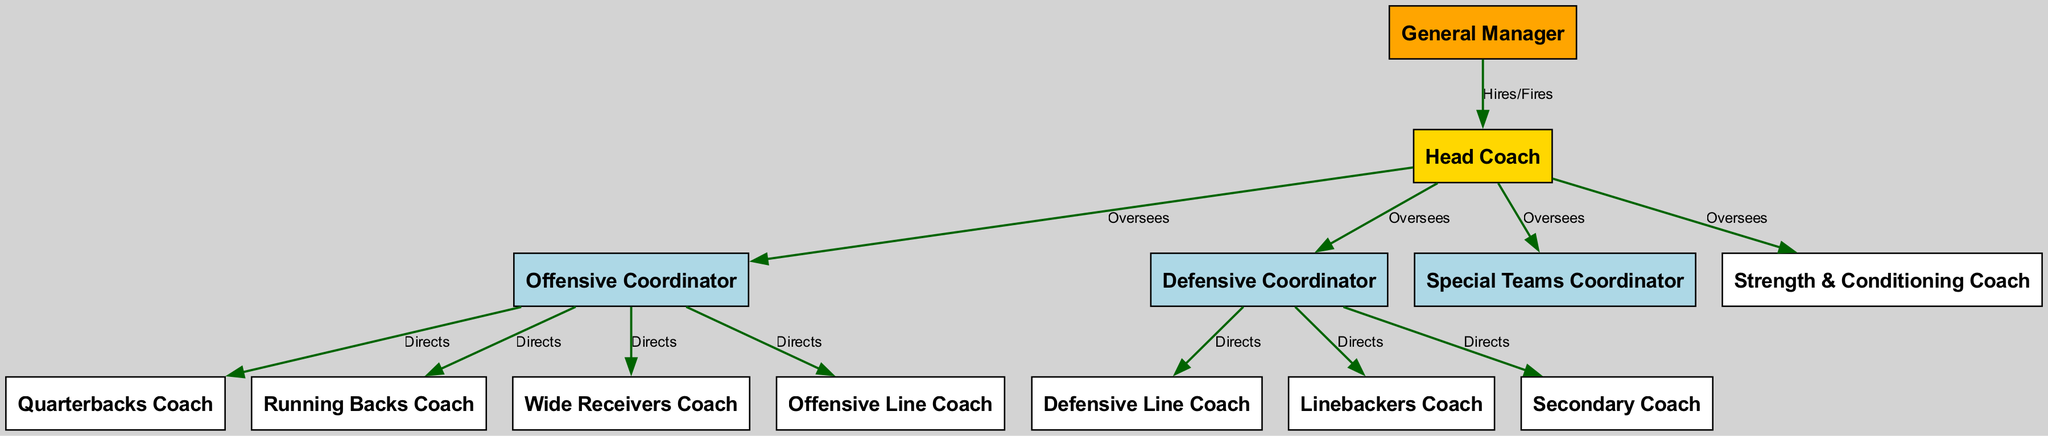What role does the General Manager have in relation to the Head Coach? The diagram shows a directed edge from General Manager to Head Coach labeled "Hires/Fires", indicating that the General Manager is responsible for hiring or firing the Head Coach.
Answer: Hires/Fires How many coaches report directly to the Offensive Coordinator? The diagram indicates that the Offensive Coordinator has directed edges to four coaches: Quarterbacks Coach, Running Backs Coach, Wide Receivers Coach, and Offensive Line Coach, totaling four coaches.
Answer: Four Which coach is responsible for the Defensive Line Coach? The directed edge from the Defensive Coordinator to the Defensive Line Coach, labeled "Directs," indicates that the Defensive Coordinator is responsible for this role.
Answer: Defensive Coordinator What is the relationship labeled for the connection between the Head Coach and the Strength & Conditioning Coach? The diagram shows a directed edge from Head Coach to Strength & Conditioning Coach with the label "Oversees," indicating this supervisory relationship.
Answer: Oversees How many total edges are present in the diagram? By counting the edges listed in the diagram, there are a total of eleven connections indicating relationships among the nodes.
Answer: Eleven Which node has the highest level of oversight in the hierarchy? The Head Coach oversees the entire offensive and defensive coaching staff as indicated by the directed edges from Head Coach to multiple coordinators and other coaches.
Answer: Head Coach What type of relationship exists between the Offensive Coordinator and the Running Backs Coach? The relationship shown in the diagram is directed with the edge labeled "Directs," indicating the Offensive Coordinator directs the Running Backs Coach.
Answer: Directs Which coach falls under the Special Teams Coordinator's oversight? The diagram does not show any direct reports to the Special Teams Coordinator, as it only connects to the Head Coach, indicating no further directed relationships.
Answer: None 